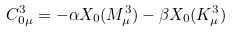Convert formula to latex. <formula><loc_0><loc_0><loc_500><loc_500>C _ { 0 \mu } ^ { 3 } = - \alpha X _ { 0 } ( M _ { \mu } ^ { 3 } ) - \beta X _ { 0 } ( K _ { \mu } ^ { 3 } )</formula> 